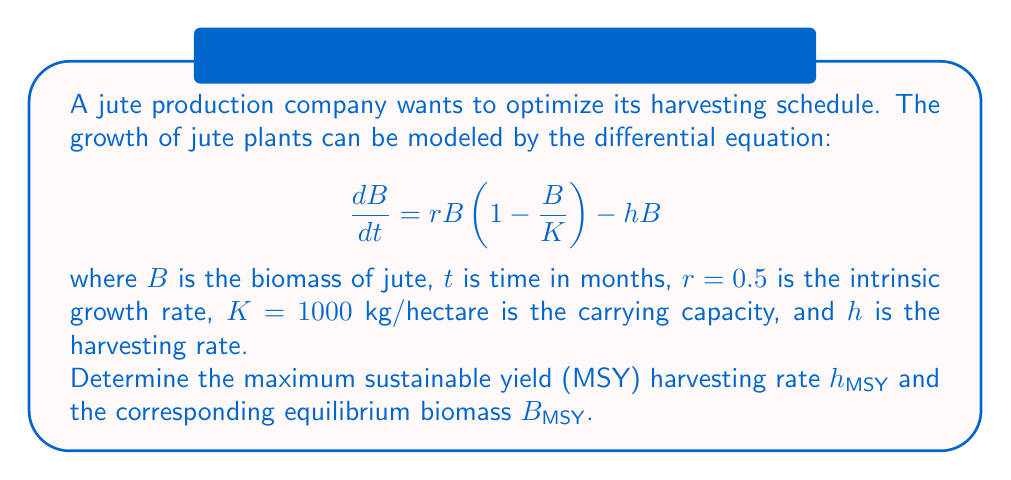Solve this math problem. To find the maximum sustainable yield (MSY), we need to follow these steps:

1) First, we find the equilibrium points by setting $\frac{dB}{dt} = 0$:

   $$0 = rB\left(1 - \frac{B}{K}\right) - hB$$

2) Solving this equation:

   $$rB - \frac{rB^2}{K} - hB = 0$$
   $$B\left(r - \frac{rB}{K} - h\right) = 0$$

   This gives us two solutions: $B = 0$ or $r - \frac{rB}{K} - h = 0$

3) We're interested in the non-zero solution. Solving for $B$:

   $$r - \frac{rB}{K} = h$$
   $$r - h = \frac{rB}{K}$$
   $$B = K\left(1 - \frac{h}{r}\right)$$

4) The sustainable yield (SY) is the product of the harvesting rate and the equilibrium biomass:

   $$SY = hB = hK\left(1 - \frac{h}{r}\right)$$

5) To find the maximum, we differentiate SY with respect to h and set it to zero:

   $$\frac{d(SY)}{dh} = K\left(1 - \frac{h}{r}\right) - \frac{hK}{r} = 0$$

6) Solving this equation:

   $$K - \frac{Kh}{r} - \frac{Kh}{r} = 0$$
   $$K = \frac{2Kh}{r}$$
   $$h = \frac{r}{2}$$

7) This gives us the MSY harvesting rate $h_{MSY} = \frac{r}{2} = 0.25$

8) To find the corresponding equilibrium biomass, we substitute this back into our equation from step 3:

   $$B_{MSY} = K\left(1 - \frac{h_{MSY}}{r}\right) = K\left(1 - \frac{r/2}{r}\right) = K\left(1 - \frac{1}{2}\right) = \frac{K}{2} = 500$$
Answer: The maximum sustainable yield (MSY) harvesting rate is $h_{MSY} = 0.25$ per month, and the corresponding equilibrium biomass is $B_{MSY} = 500$ kg/hectare. 